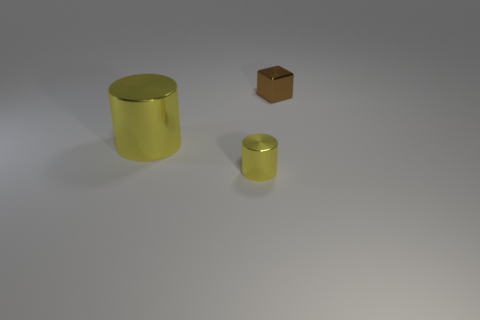Are the tiny thing that is to the right of the tiny metallic cylinder and the tiny thing that is in front of the brown object made of the same material?
Provide a succinct answer. Yes. Is there anything else that is the same shape as the small yellow object?
Your answer should be compact. Yes. The tiny metallic block has what color?
Provide a succinct answer. Brown. What number of other objects have the same shape as the big metal object?
Your answer should be compact. 1. The shiny cylinder that is the same size as the brown shiny object is what color?
Offer a very short reply. Yellow. Are there any large cyan rubber things?
Offer a terse response. No. There is a yellow metal object right of the big metal cylinder; what is its shape?
Offer a terse response. Cylinder. How many metal things are behind the large yellow metal thing and in front of the large metal thing?
Make the answer very short. 0. Is there a tiny yellow object that has the same material as the small brown block?
Offer a terse response. Yes. What is the size of the other shiny cylinder that is the same color as the small cylinder?
Your response must be concise. Large. 